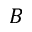Convert formula to latex. <formula><loc_0><loc_0><loc_500><loc_500>B</formula> 